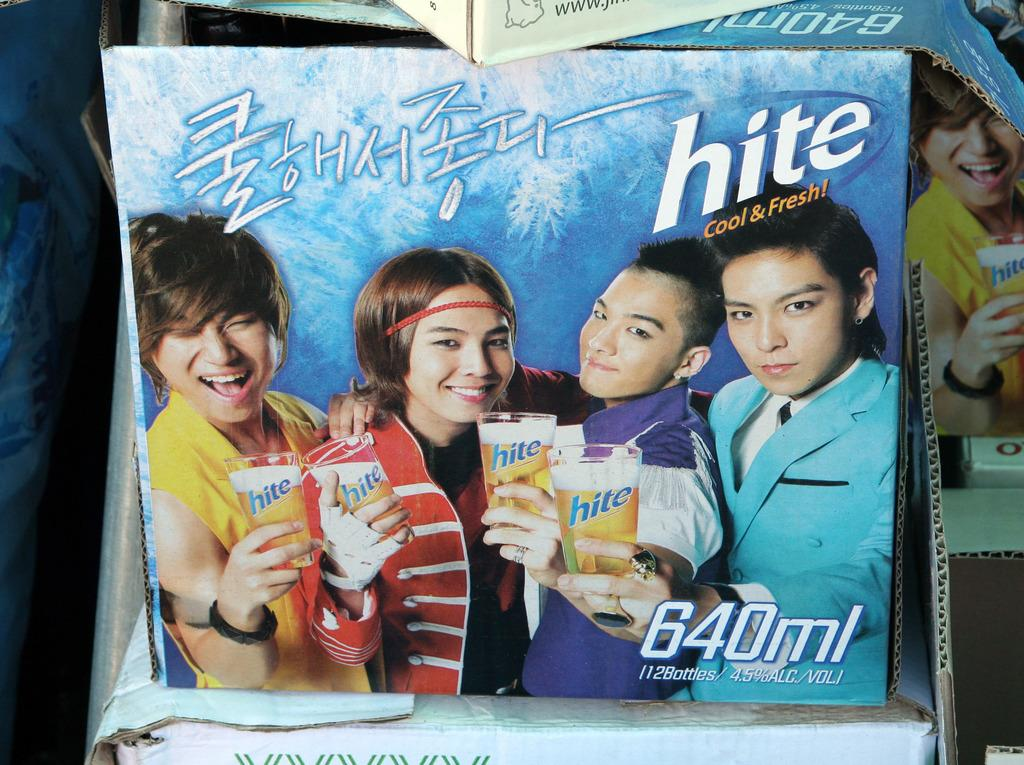How many people are in the image? There are four people in the image. What are the people doing in the image? The people are standing and holding beer glasses. What expressions do the people have in the image? The people are smiling in the image. What type of fact card can be seen in the image? There is no fact card present in the image. What type of show are the people attending in the image? There is no indication of a show or event in the image; the people are simply standing and holding beer glasses. 